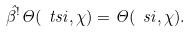<formula> <loc_0><loc_0><loc_500><loc_500>\hat { \beta } ^ { ! } \Theta ( \ t s i , \chi ) = \Theta ( \ s i , \chi ) .</formula> 